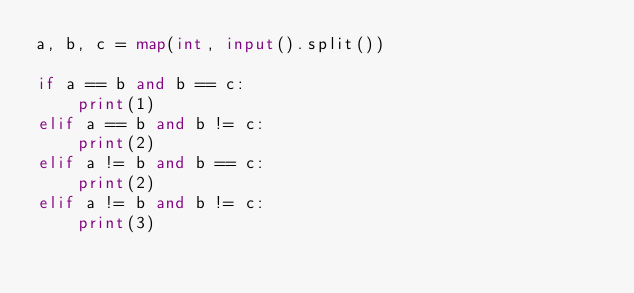<code> <loc_0><loc_0><loc_500><loc_500><_Python_>a, b, c = map(int, input().split())

if a == b and b == c:
    print(1)
elif a == b and b != c:
    print(2)
elif a != b and b == c:
    print(2)
elif a != b and b != c:
    print(3)</code> 